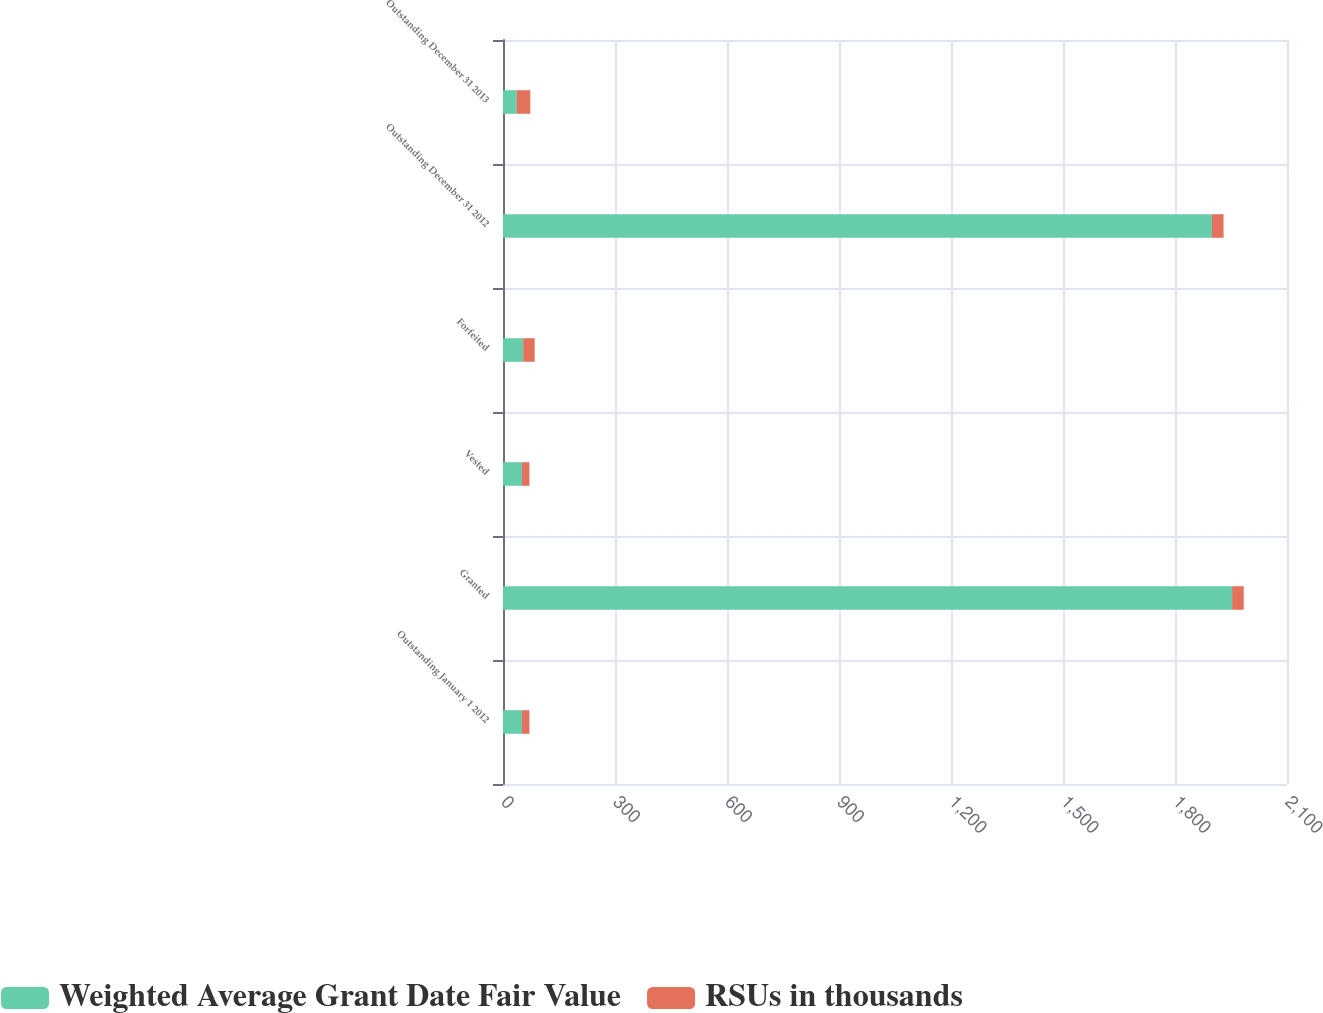Convert chart. <chart><loc_0><loc_0><loc_500><loc_500><stacked_bar_chart><ecel><fcel>Outstanding January 1 2012<fcel>Granted<fcel>Vested<fcel>Forfeited<fcel>Outstanding December 31 2012<fcel>Outstanding December 31 2013<nl><fcel>Weighted Average Grant Date Fair Value<fcel>51<fcel>1953<fcel>51<fcel>54<fcel>1899<fcel>36.55<nl><fcel>RSUs in thousands<fcel>19.9<fcel>31.08<fcel>19.9<fcel>30.81<fcel>31.09<fcel>36.55<nl></chart> 